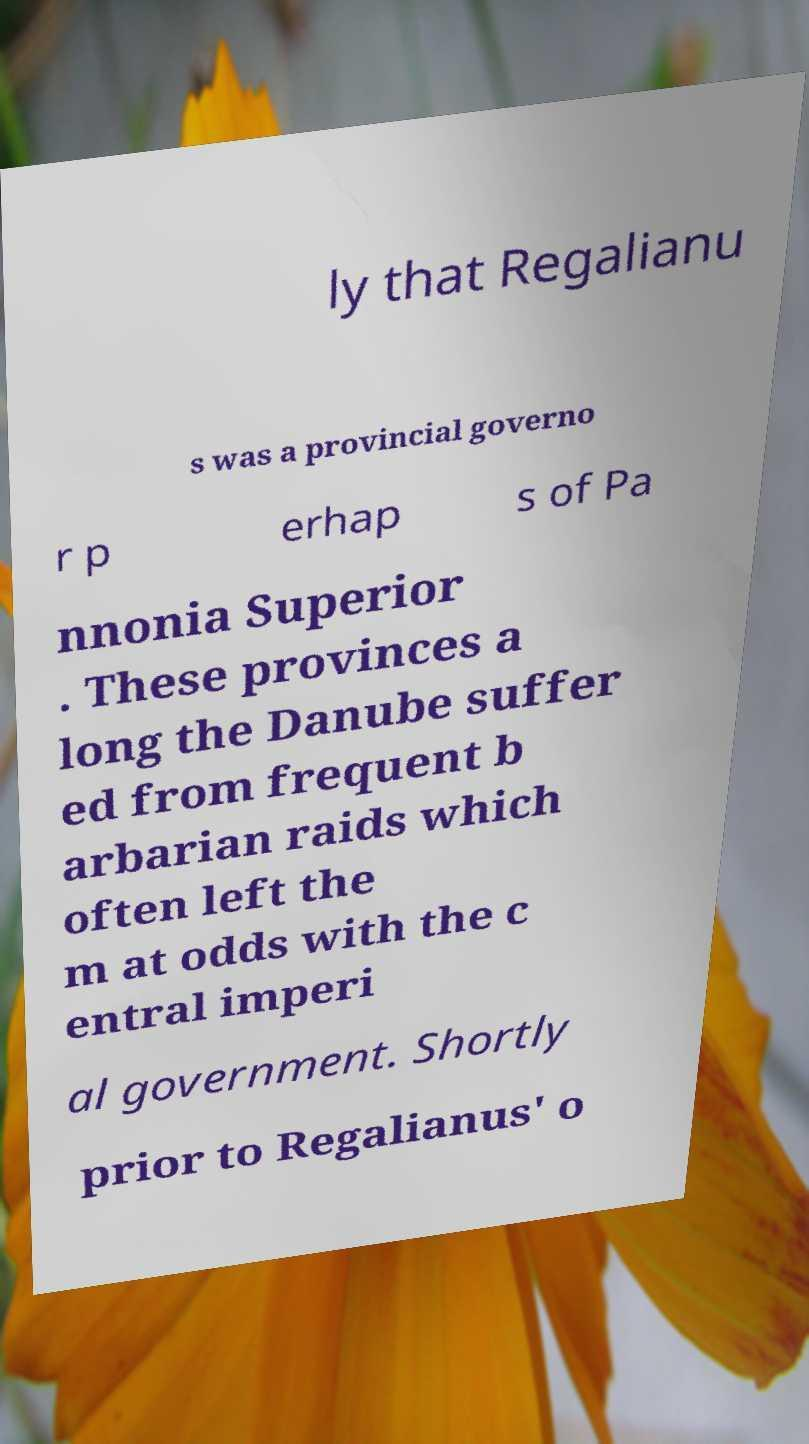I need the written content from this picture converted into text. Can you do that? ly that Regalianu s was a provincial governo r p erhap s of Pa nnonia Superior . These provinces a long the Danube suffer ed from frequent b arbarian raids which often left the m at odds with the c entral imperi al government. Shortly prior to Regalianus' o 